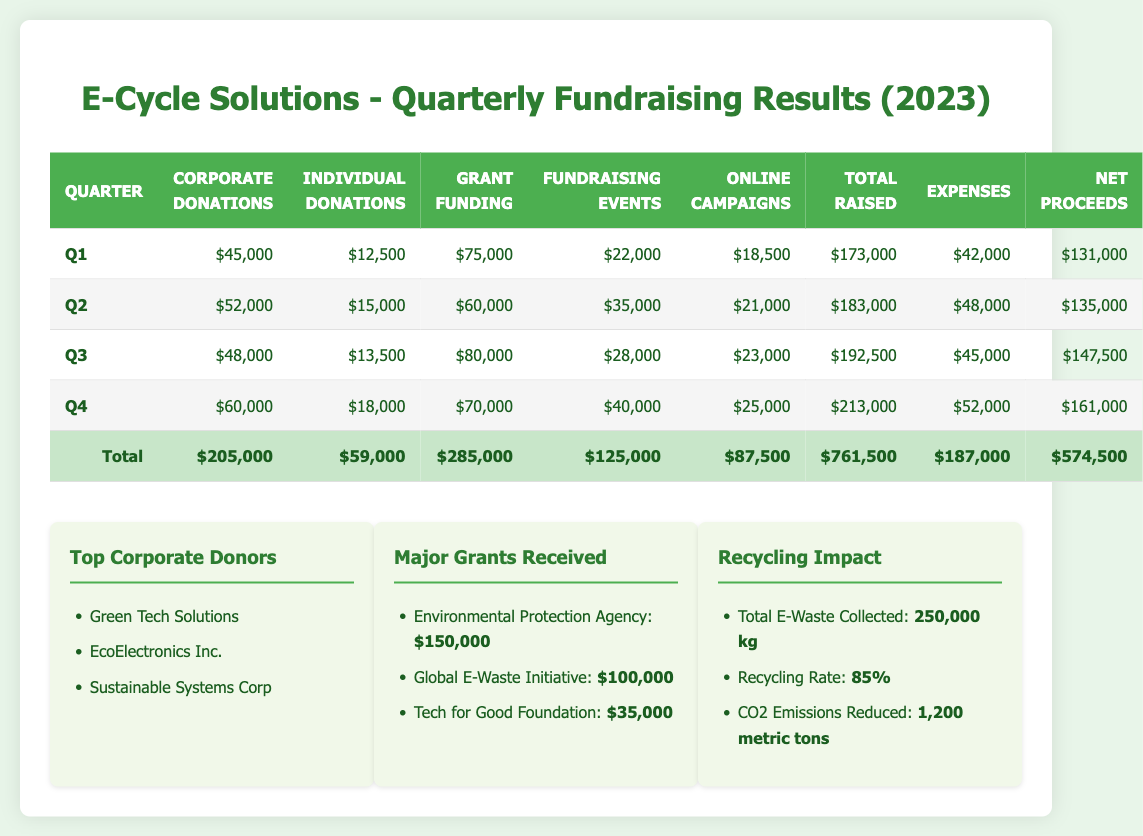What was the total amount raised in Q3? The total amount raised in Q3 is found in the table under the "Total Raised" column for Q3, which shows $192,500.
Answer: $192,500 How much did individual donations increase from Q1 to Q4? To find the increase, we subtract the individual donations in Q1 ($12,500) from those in Q4 ($18,000): $18,000 - $12,500 = $5,500.
Answer: $5,500 Did E-Cycle Solutions raise more in Q4 than in Q3? By comparing the "Total Raised" values, Q4 raised $213,000 while Q3 raised $192,500. Since $213,000 > $192,500, the statement is true.
Answer: Yes What is the average expense per quarter for the year? To find the average expense, sum the expenses of all quarters: $42,000 + $48,000 + $45,000 + $52,000 = $187,000. Then divide by the number of quarters (4): $187,000 / 4 = $46,750.
Answer: $46,750 What was the total amount raised across all quarters? The total raised is found by summing the "Total Raised" values of each quarter: $173,000 + $183,000 + $192,500 + $213,000 = $761,500.
Answer: $761,500 Which quarter had the highest net proceeds? By comparing the "Net Proceeds" for each quarter, Q4 has $161,000, Q3 has $147,500, Q2 has $135,000, and Q1 has $131,000. Q4 has the highest amount.
Answer: Q4 How much did grant funding contribute to total fundraising for the year? Total grant funding across all quarters is: $75,000 (Q1) + $60,000 (Q2) + $80,000 (Q3) + $70,000 (Q4) = $285,000. This shows the contribution was significant.
Answer: $285,000 Was the total collected e-waste higher than the total amount raised? The total e-waste collected was 250,000 kg. The total raised is $761,500. Since these values are not directly comparable (one is a weight and the other is a monetary value), the statement is not applicable.
Answer: Not applicable How much more did corporate donations contribute in Q4 compared to Q1? The corporate donations in Q4 were $60,000, and in Q1 they were $45,000. The difference is $60,000 - $45,000 = $15,000, meaning that corporate donations increased.
Answer: $15,000 